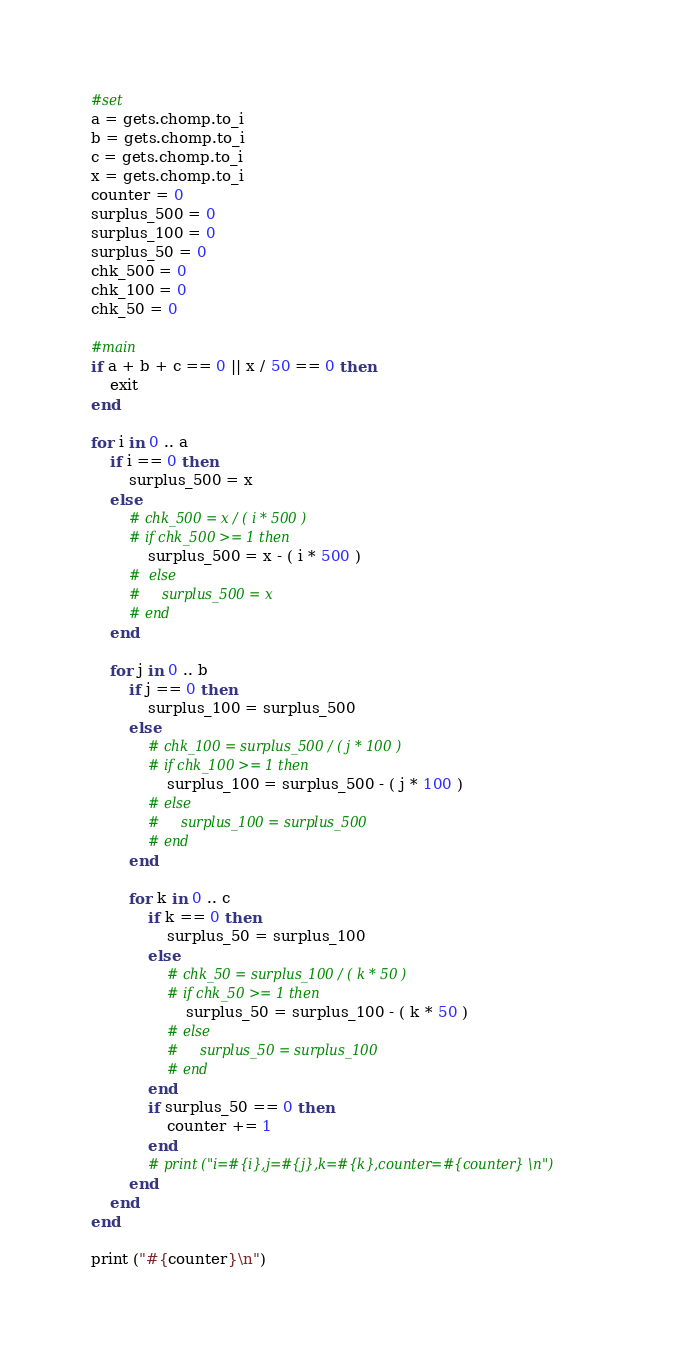<code> <loc_0><loc_0><loc_500><loc_500><_Ruby_>#set
a = gets.chomp.to_i
b = gets.chomp.to_i
c = gets.chomp.to_i
x = gets.chomp.to_i
counter = 0
surplus_500 = 0
surplus_100 = 0
surplus_50 = 0
chk_500 = 0
chk_100 = 0
chk_50 = 0

#main
if a + b + c == 0 || x / 50 == 0 then
    exit
end

for i in 0 .. a 
    if i == 0 then 
        surplus_500 = x
    else
        # chk_500 = x / ( i * 500 ) 
        # if chk_500 >= 1 then
            surplus_500 = x - ( i * 500 )
        #  else
        #     surplus_500 = x
        # end
    end

    for j in 0 .. b
        if j == 0 then
            surplus_100 = surplus_500
        else
            # chk_100 = surplus_500 / ( j * 100 ) 
            # if chk_100 >= 1 then
                surplus_100 = surplus_500 - ( j * 100 )
            # else
            #     surplus_100 = surplus_500
            # end 
        end

        for k in 0 .. c
            if k == 0 then
                surplus_50 = surplus_100
            else
                # chk_50 = surplus_100 / ( k * 50 )
                # if chk_50 >= 1 then
                    surplus_50 = surplus_100 - ( k * 50 )
                # else
                #     surplus_50 = surplus_100
                # end
            end
            if surplus_50 == 0 then
                counter += 1
            end
            # print ("i=#{i},j=#{j},k=#{k},counter=#{counter} \n")
        end
    end
end

print ("#{counter}\n")</code> 